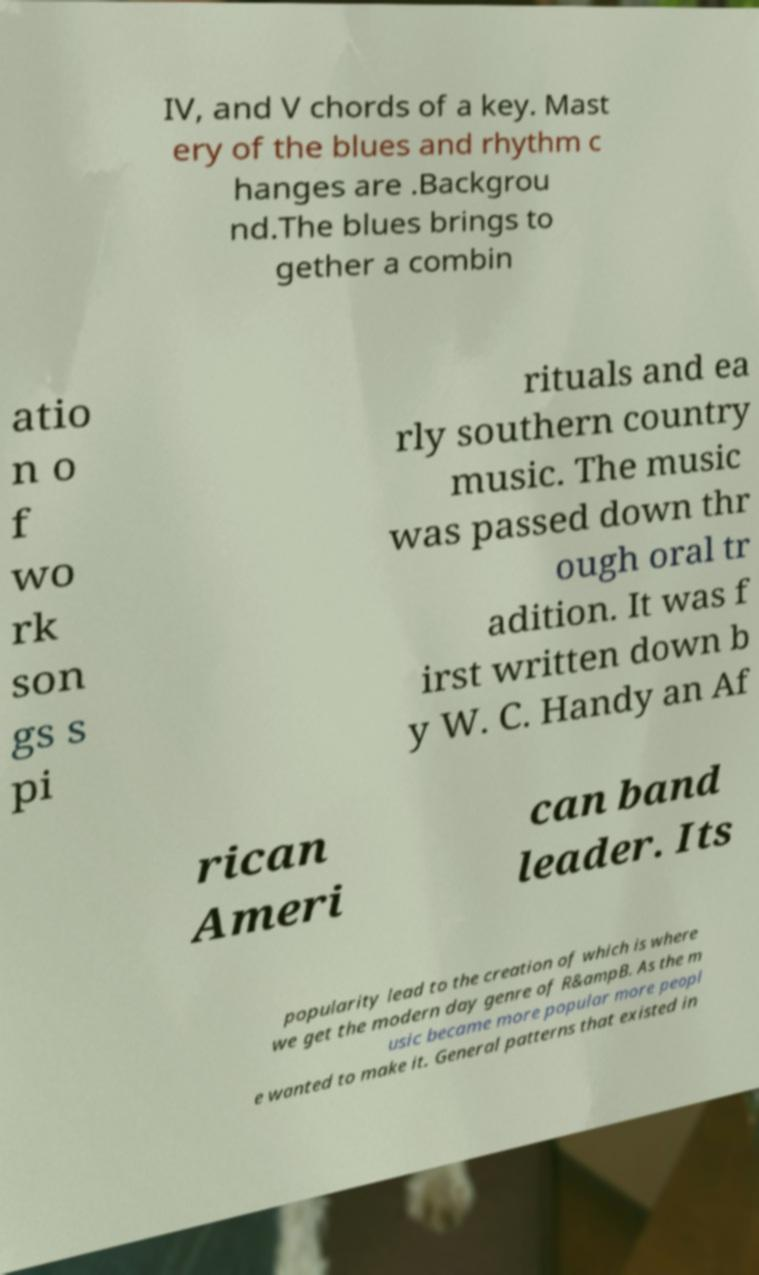For documentation purposes, I need the text within this image transcribed. Could you provide that? IV, and V chords of a key. Mast ery of the blues and rhythm c hanges are .Backgrou nd.The blues brings to gether a combin atio n o f wo rk son gs s pi rituals and ea rly southern country music. The music was passed down thr ough oral tr adition. It was f irst written down b y W. C. Handy an Af rican Ameri can band leader. Its popularity lead to the creation of which is where we get the modern day genre of R&ampB. As the m usic became more popular more peopl e wanted to make it. General patterns that existed in 